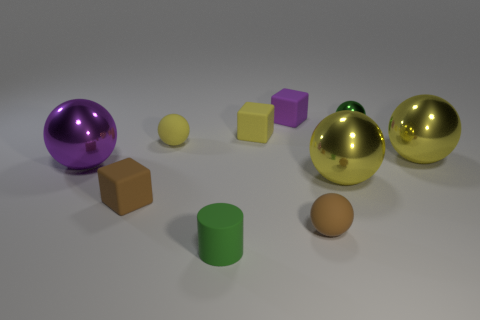The shiny object that is the same size as the purple cube is what shape?
Provide a short and direct response. Sphere. Are there any large metallic objects of the same shape as the small purple matte thing?
Keep it short and to the point. No. Is the brown sphere made of the same material as the purple thing that is right of the matte cylinder?
Offer a very short reply. Yes. What color is the large object that is to the left of the small green matte cylinder that is on the right side of the yellow sphere that is on the left side of the small green rubber cylinder?
Offer a terse response. Purple. There is a brown cube that is the same size as the purple matte block; what material is it?
Ensure brevity in your answer.  Rubber. What number of other small purple cubes have the same material as the purple cube?
Keep it short and to the point. 0. Do the yellow thing that is in front of the purple metallic object and the object that is behind the small green sphere have the same size?
Your answer should be compact. No. What color is the matte ball that is to the left of the tiny purple matte block?
Provide a succinct answer. Yellow. There is a small ball that is the same color as the tiny rubber cylinder; what is it made of?
Make the answer very short. Metal. What number of large things are the same color as the rubber cylinder?
Ensure brevity in your answer.  0. 